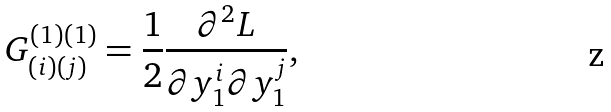<formula> <loc_0><loc_0><loc_500><loc_500>G _ { ( i ) ( j ) } ^ { ( 1 ) ( 1 ) } = \frac { 1 } { 2 } \frac { \partial ^ { 2 } L } { \partial y _ { 1 } ^ { i } \partial y _ { 1 } ^ { j } } ,</formula> 